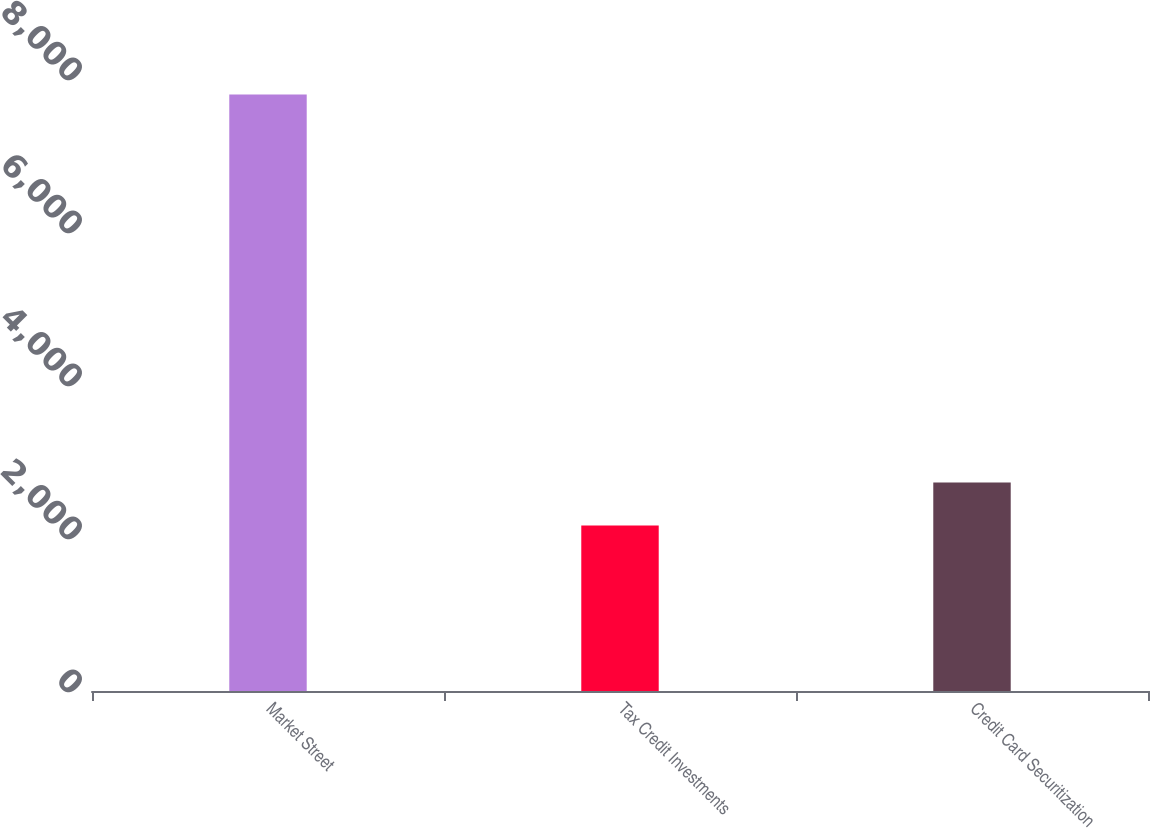<chart> <loc_0><loc_0><loc_500><loc_500><bar_chart><fcel>Market Street<fcel>Tax Credit Investments<fcel>Credit Card Securitization<nl><fcel>7796<fcel>2162<fcel>2725.4<nl></chart> 